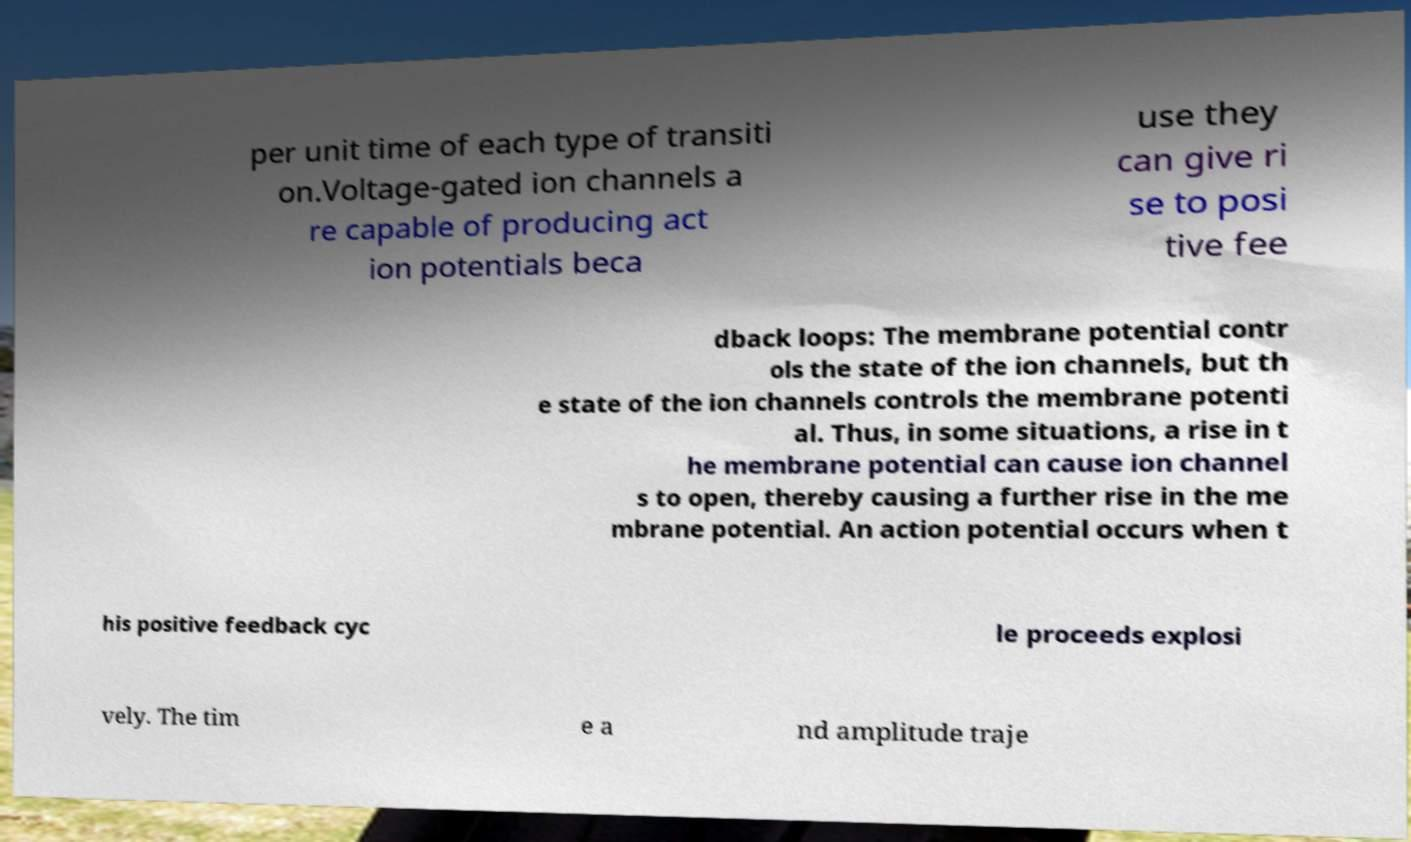Can you accurately transcribe the text from the provided image for me? per unit time of each type of transiti on.Voltage-gated ion channels a re capable of producing act ion potentials beca use they can give ri se to posi tive fee dback loops: The membrane potential contr ols the state of the ion channels, but th e state of the ion channels controls the membrane potenti al. Thus, in some situations, a rise in t he membrane potential can cause ion channel s to open, thereby causing a further rise in the me mbrane potential. An action potential occurs when t his positive feedback cyc le proceeds explosi vely. The tim e a nd amplitude traje 